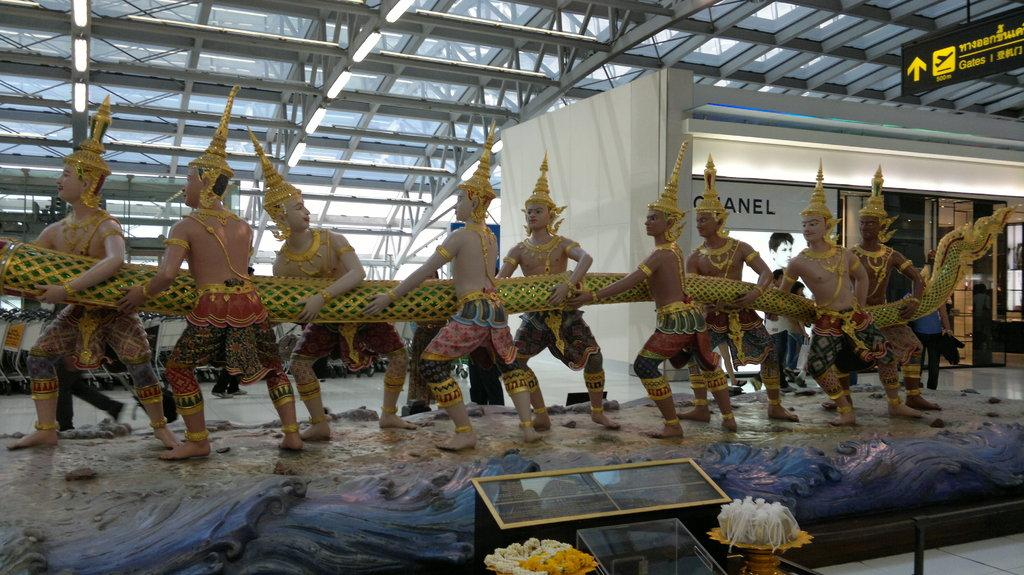What type of objects are the main subjects in the image? There are people statues in the image. What are the statues doing in the image? The statues are holding something. What is the color of the board in the image? There is a white color board in the image. What other object can be seen in the image? There is a flowerpot in the image. Are there any other objects present in the image besides the statues, color board, and flowerpot? Yes, there are other objects present in the image. How many balloons are being held by the people statues in the image? There are no balloons present in the image; the statues are holding something else. What type of class is being conducted in the image? There is no indication of a class or any educational activity in the image. 